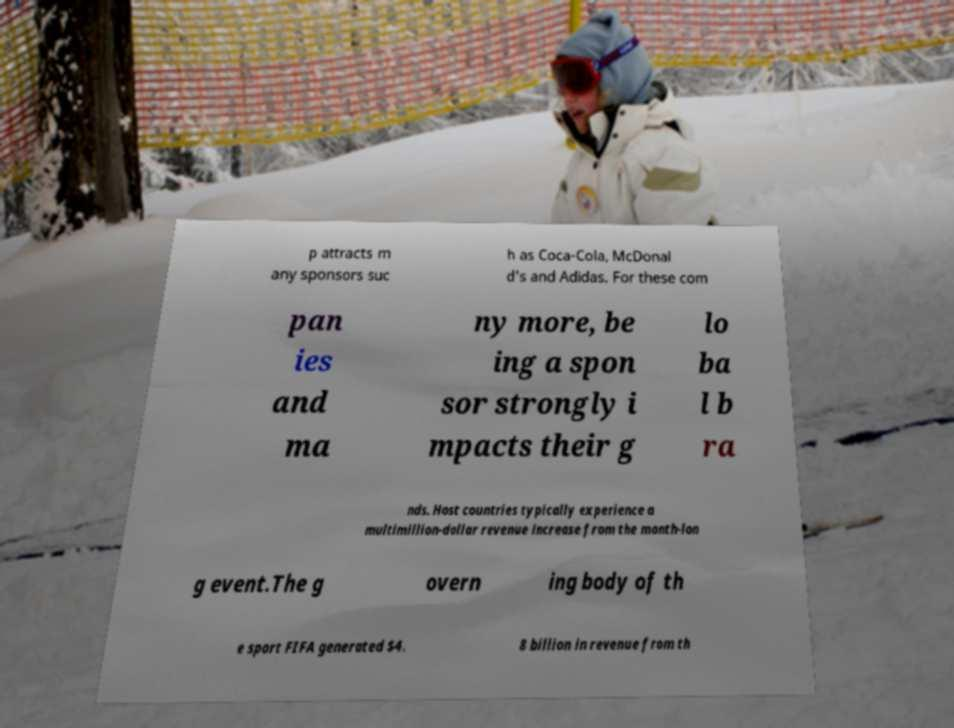What messages or text are displayed in this image? I need them in a readable, typed format. p attracts m any sponsors suc h as Coca-Cola, McDonal d's and Adidas. For these com pan ies and ma ny more, be ing a spon sor strongly i mpacts their g lo ba l b ra nds. Host countries typically experience a multimillion-dollar revenue increase from the month-lon g event.The g overn ing body of th e sport FIFA generated $4. 8 billion in revenue from th 